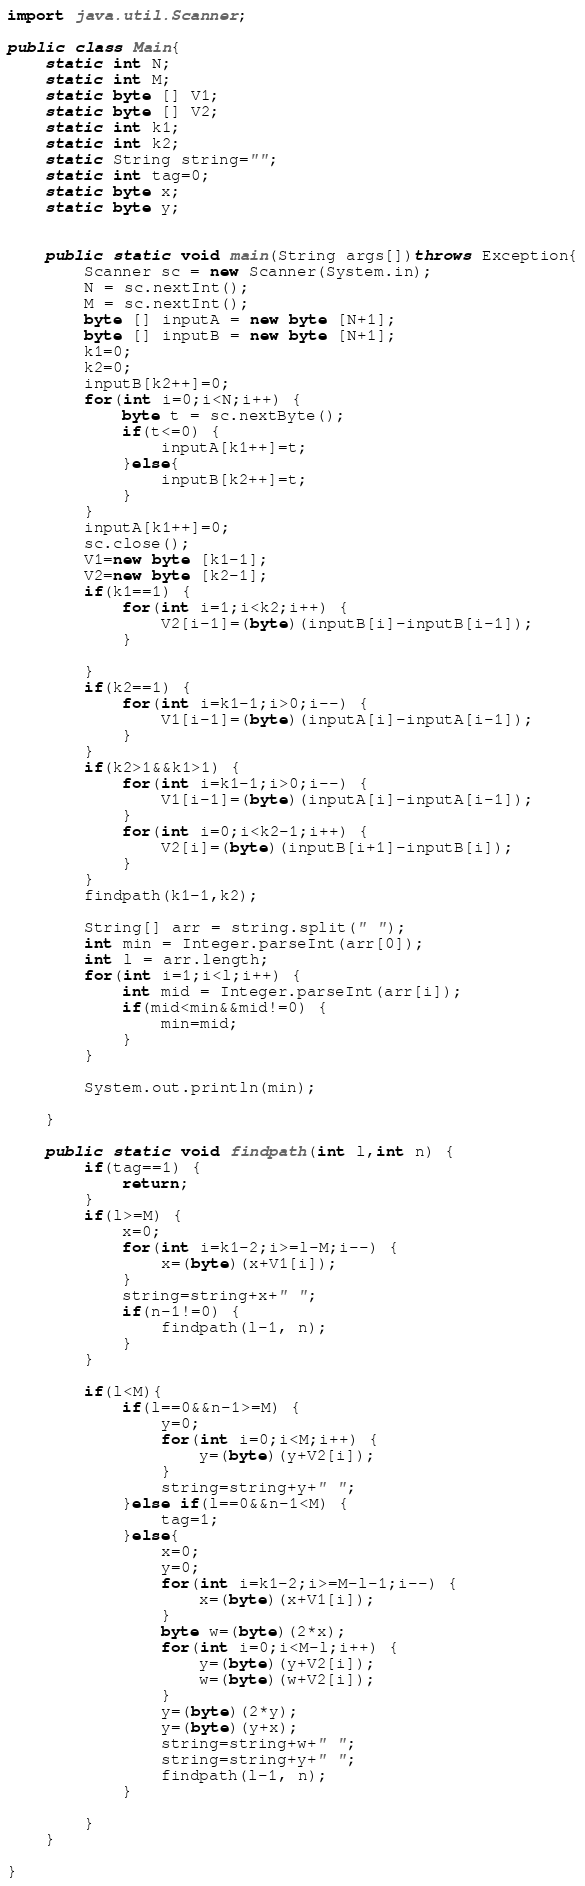<code> <loc_0><loc_0><loc_500><loc_500><_Java_>import java.util.Scanner;

public class Main{
	static int N;
	static int M;
	static byte [] V1;
	static byte [] V2;
	static int k1;
	static int k2;
	static String string="";
	static int tag=0;
	static byte x;
	static byte y;
	
	
	public static void main(String args[])throws Exception{
		Scanner sc = new Scanner(System.in);
		N = sc.nextInt();
		M = sc.nextInt();
		byte [] inputA = new byte [N+1];
		byte [] inputB = new byte [N+1];
		k1=0;
		k2=0;
		inputB[k2++]=0;
		for(int i=0;i<N;i++) {
			byte t = sc.nextByte();
			if(t<=0) {
				inputA[k1++]=t;
			}else{
				inputB[k2++]=t;
			}
		}
		inputA[k1++]=0;
		sc.close();
		V1=new byte [k1-1];
		V2=new byte [k2-1];
		if(k1==1) {
			for(int i=1;i<k2;i++) {
				V2[i-1]=(byte)(inputB[i]-inputB[i-1]);
			}
			
		}
		if(k2==1) {
			for(int i=k1-1;i>0;i--) {
				V1[i-1]=(byte)(inputA[i]-inputA[i-1]);
			}
		}
		if(k2>1&&k1>1) {
			for(int i=k1-1;i>0;i--) {
				V1[i-1]=(byte)(inputA[i]-inputA[i-1]);
			}
			for(int i=0;i<k2-1;i++) {
				V2[i]=(byte)(inputB[i+1]-inputB[i]);
			}
		}
		findpath(k1-1,k2);
		
		String[] arr = string.split(" ");
		int min = Integer.parseInt(arr[0]);
		int l = arr.length;
		for(int i=1;i<l;i++) {
			int mid = Integer.parseInt(arr[i]);
			if(mid<min&&mid!=0) {
				min=mid;
			}
		}
		
		System.out.println(min);
		
	}
	
	public static void findpath(int l,int n) {
		if(tag==1) {
			return;
		}
		if(l>=M) {
			x=0;
			for(int i=k1-2;i>=l-M;i--) {
				x=(byte)(x+V1[i]);
			}
			string=string+x+" ";
			if(n-1!=0) {
				findpath(l-1, n);
			}
		}
		
		if(l<M){
			if(l==0&&n-1>=M) {
				y=0;
				for(int i=0;i<M;i++) {
					y=(byte)(y+V2[i]);
				}
				string=string+y+" ";
			}else if(l==0&&n-1<M) {
				tag=1;
			}else{
				x=0;
				y=0;
				for(int i=k1-2;i>=M-l-1;i--) {
					x=(byte)(x+V1[i]);
				}
				byte w=(byte)(2*x);
				for(int i=0;i<M-l;i++) {
					y=(byte)(y+V2[i]);
					w=(byte)(w+V2[i]);
				}
				y=(byte)(2*y);
				y=(byte)(y+x);
				string=string+w+" ";
				string=string+y+" ";
				findpath(l-1, n);
			}
			
		}
	}

}
</code> 